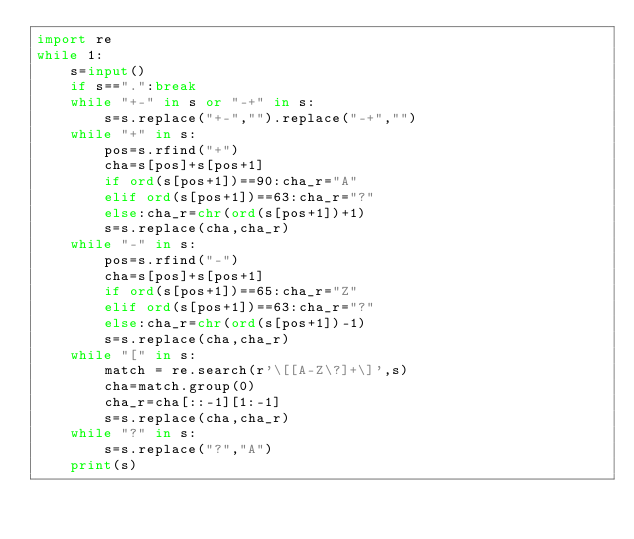Convert code to text. <code><loc_0><loc_0><loc_500><loc_500><_Python_>import re
while 1:
    s=input()
    if s==".":break
    while "+-" in s or "-+" in s:
        s=s.replace("+-","").replace("-+","")
    while "+" in s:
        pos=s.rfind("+")
        cha=s[pos]+s[pos+1]
        if ord(s[pos+1])==90:cha_r="A"
        elif ord(s[pos+1])==63:cha_r="?"
        else:cha_r=chr(ord(s[pos+1])+1)
        s=s.replace(cha,cha_r)
    while "-" in s:
        pos=s.rfind("-")
        cha=s[pos]+s[pos+1]
        if ord(s[pos+1])==65:cha_r="Z"
        elif ord(s[pos+1])==63:cha_r="?"
        else:cha_r=chr(ord(s[pos+1])-1)
        s=s.replace(cha,cha_r)
    while "[" in s:
        match = re.search(r'\[[A-Z\?]+\]',s)
        cha=match.group(0)
        cha_r=cha[::-1][1:-1]
        s=s.replace(cha,cha_r)
    while "?" in s:
        s=s.replace("?","A")
    print(s)
</code> 